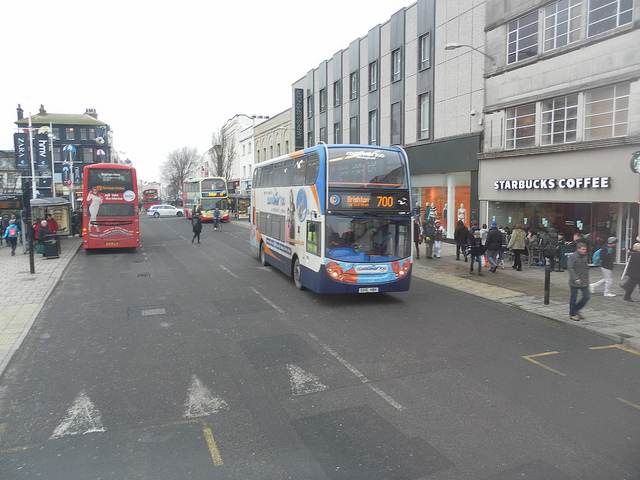Suppose the buses here could talk. What conversation would they have? The double-decker buses, parked side by side, began their daily chat as their engines idled. 'Another busy day ahead,' sighed the lead bus. 'Indeed,' replied the bus behind it, 'Lots of commuters today. Hope the traffic isn't too bad.' The third bus, newer and shinier, chimed in, 'I overheard the drivers talking about a parade this weekend. That should be fun!' The buses exchanged stories of their journeys, the people they carried, and the places they visited. They were not just machines but silent witnesses to the lives and stories of the city’s residents, each ride an unwritten chapter in the book of the city’s vibrant life. 